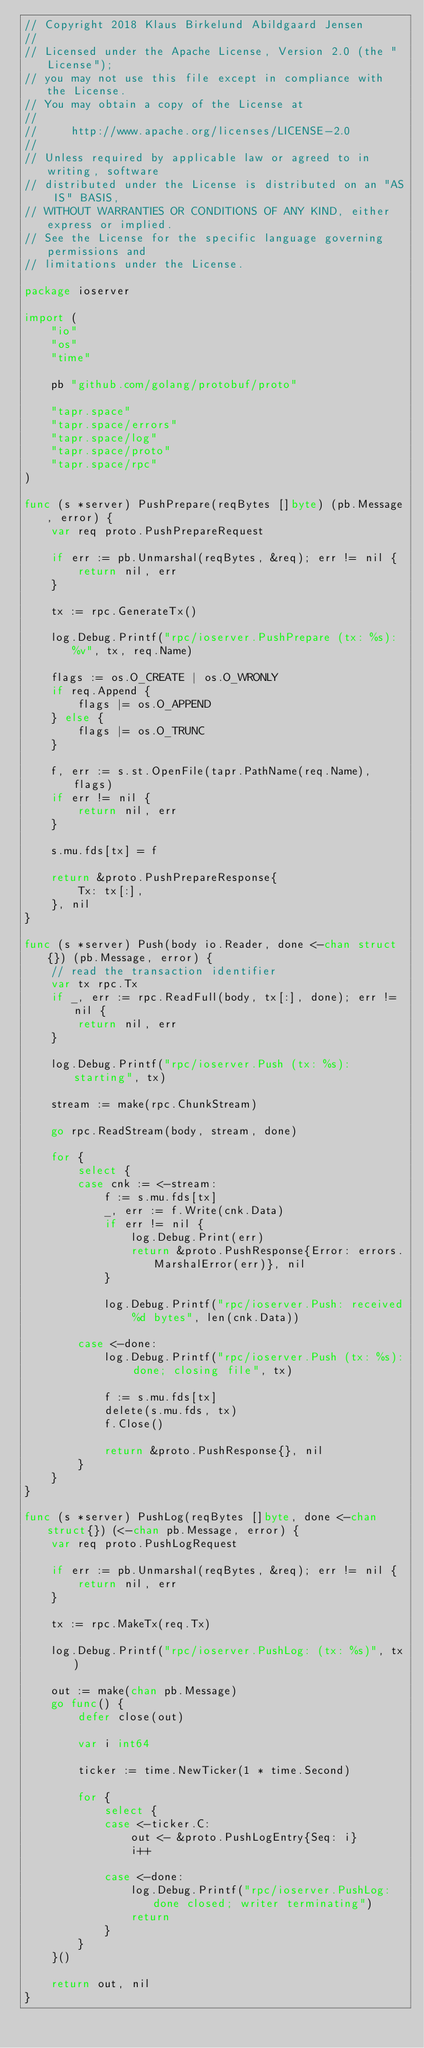<code> <loc_0><loc_0><loc_500><loc_500><_Go_>// Copyright 2018 Klaus Birkelund Abildgaard Jensen
//
// Licensed under the Apache License, Version 2.0 (the "License");
// you may not use this file except in compliance with the License.
// You may obtain a copy of the License at
//
//     http://www.apache.org/licenses/LICENSE-2.0
//
// Unless required by applicable law or agreed to in writing, software
// distributed under the License is distributed on an "AS IS" BASIS,
// WITHOUT WARRANTIES OR CONDITIONS OF ANY KIND, either express or implied.
// See the License for the specific language governing permissions and
// limitations under the License.

package ioserver

import (
	"io"
	"os"
	"time"

	pb "github.com/golang/protobuf/proto"

	"tapr.space"
	"tapr.space/errors"
	"tapr.space/log"
	"tapr.space/proto"
	"tapr.space/rpc"
)

func (s *server) PushPrepare(reqBytes []byte) (pb.Message, error) {
	var req proto.PushPrepareRequest

	if err := pb.Unmarshal(reqBytes, &req); err != nil {
		return nil, err
	}

	tx := rpc.GenerateTx()

	log.Debug.Printf("rpc/ioserver.PushPrepare (tx: %s): %v", tx, req.Name)

	flags := os.O_CREATE | os.O_WRONLY
	if req.Append {
		flags |= os.O_APPEND
	} else {
		flags |= os.O_TRUNC
	}

	f, err := s.st.OpenFile(tapr.PathName(req.Name), flags)
	if err != nil {
		return nil, err
	}

	s.mu.fds[tx] = f

	return &proto.PushPrepareResponse{
		Tx: tx[:],
	}, nil
}

func (s *server) Push(body io.Reader, done <-chan struct{}) (pb.Message, error) {
	// read the transaction identifier
	var tx rpc.Tx
	if _, err := rpc.ReadFull(body, tx[:], done); err != nil {
		return nil, err
	}

	log.Debug.Printf("rpc/ioserver.Push (tx: %s): starting", tx)

	stream := make(rpc.ChunkStream)

	go rpc.ReadStream(body, stream, done)

	for {
		select {
		case cnk := <-stream:
			f := s.mu.fds[tx]
			_, err := f.Write(cnk.Data)
			if err != nil {
				log.Debug.Print(err)
				return &proto.PushResponse{Error: errors.MarshalError(err)}, nil
			}

			log.Debug.Printf("rpc/ioserver.Push: received %d bytes", len(cnk.Data))

		case <-done:
			log.Debug.Printf("rpc/ioserver.Push (tx: %s): done; closing file", tx)

			f := s.mu.fds[tx]
			delete(s.mu.fds, tx)
			f.Close()

			return &proto.PushResponse{}, nil
		}
	}
}

func (s *server) PushLog(reqBytes []byte, done <-chan struct{}) (<-chan pb.Message, error) {
	var req proto.PushLogRequest

	if err := pb.Unmarshal(reqBytes, &req); err != nil {
		return nil, err
	}

	tx := rpc.MakeTx(req.Tx)

	log.Debug.Printf("rpc/ioserver.PushLog: (tx: %s)", tx)

	out := make(chan pb.Message)
	go func() {
		defer close(out)

		var i int64

		ticker := time.NewTicker(1 * time.Second)

		for {
			select {
			case <-ticker.C:
				out <- &proto.PushLogEntry{Seq: i}
				i++

			case <-done:
				log.Debug.Printf("rpc/ioserver.PushLog: done closed; writer terminating")
				return
			}
		}
	}()

	return out, nil
}
</code> 